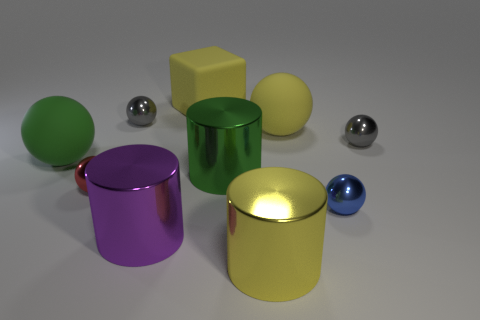Subtract all green spheres. How many spheres are left? 5 Subtract all tiny gray balls. How many balls are left? 4 Subtract all blue spheres. Subtract all green cylinders. How many spheres are left? 5 Subtract all spheres. How many objects are left? 4 Subtract all tiny red metallic things. Subtract all red objects. How many objects are left? 8 Add 3 matte spheres. How many matte spheres are left? 5 Add 5 big brown objects. How many big brown objects exist? 5 Subtract 1 red balls. How many objects are left? 9 